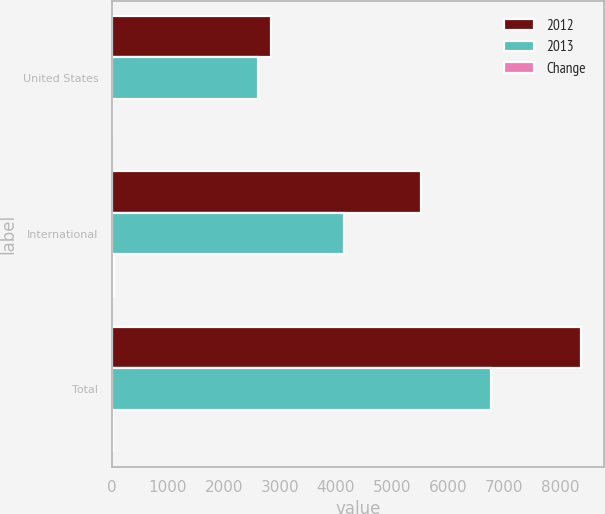<chart> <loc_0><loc_0><loc_500><loc_500><stacked_bar_chart><ecel><fcel>United States<fcel>International<fcel>Total<nl><fcel>2012<fcel>2847<fcel>5517<fcel>8364<nl><fcel>2013<fcel>2609<fcel>4149<fcel>6758<nl><fcel>Change<fcel>9<fcel>33<fcel>24<nl></chart> 